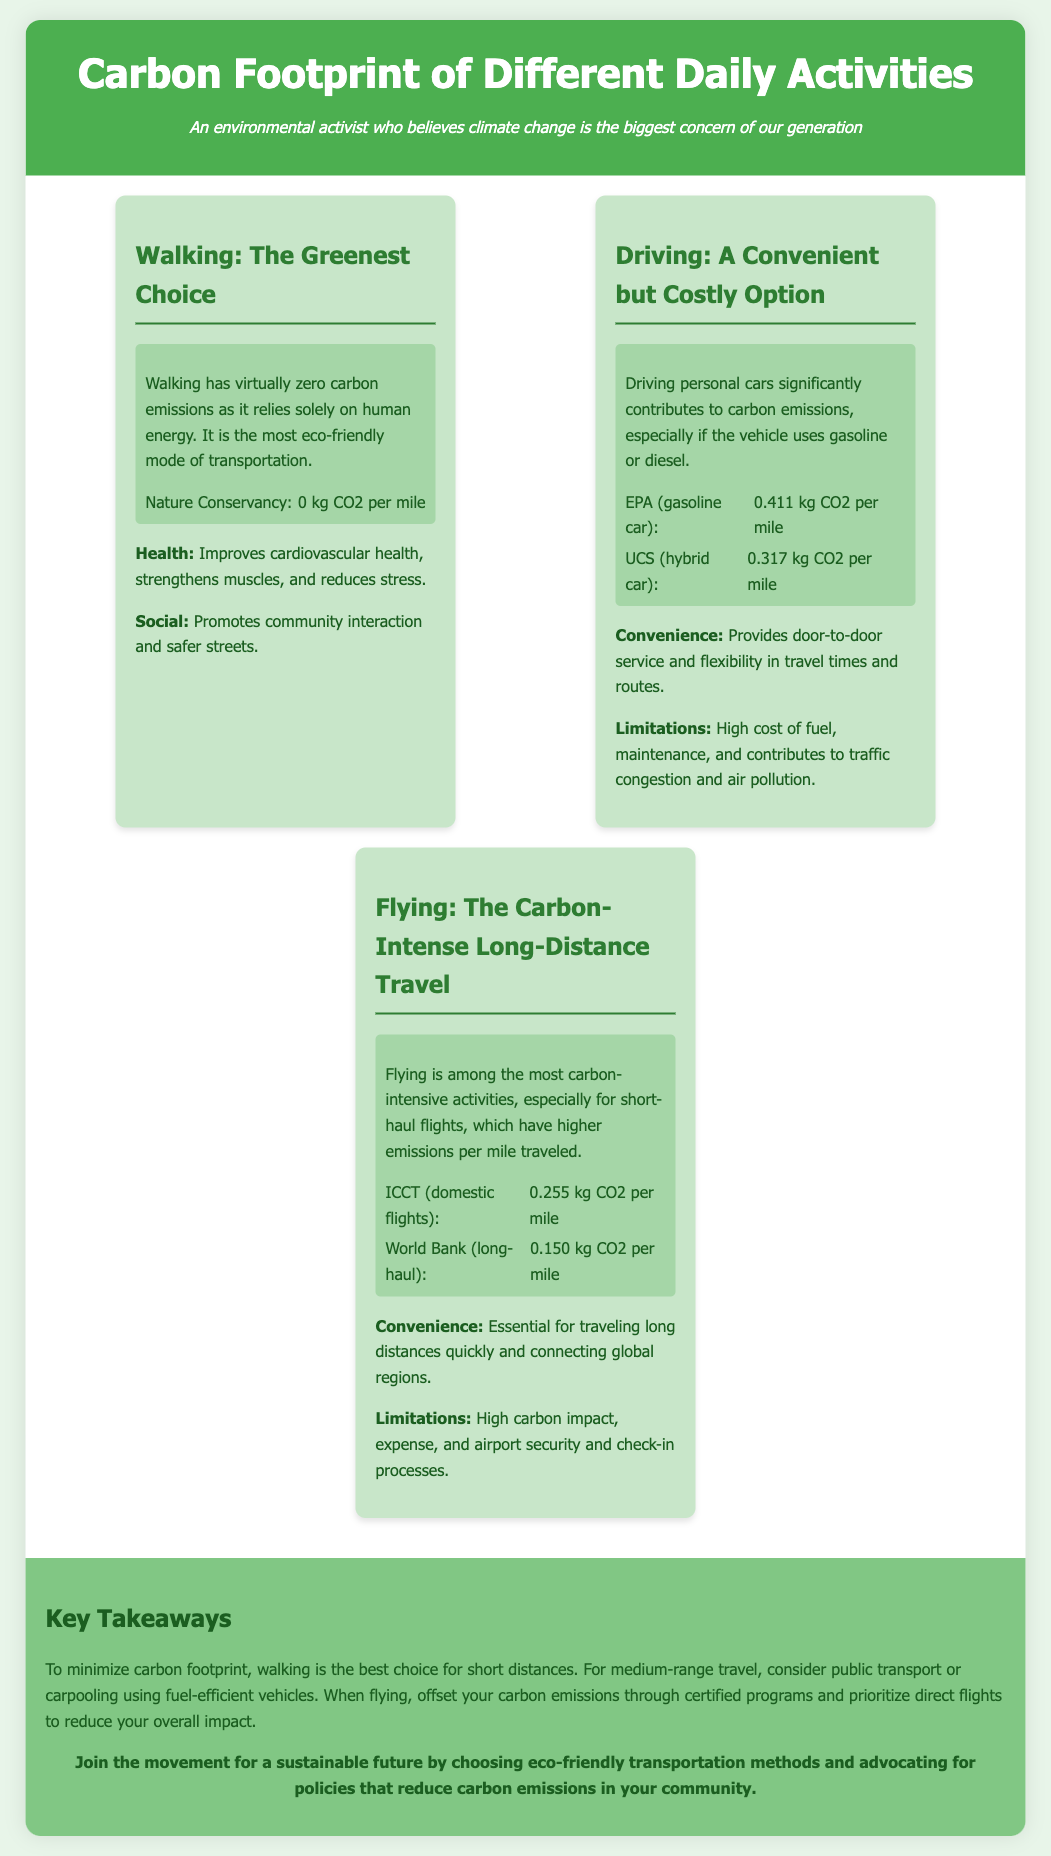What is the carbon footprint of walking? The document states that walking has virtually zero carbon emissions.
Answer: 0 kg CO2 per mile What is the carbon footprint of a gasoline car? The document provides specific figures for carbon emissions from a gasoline car.
Answer: 0.411 kg CO2 per mile How does the carbon footprint of flying compare to driving? The document implies that flying is more carbon-intensive than driving by providing specific CO2 emissions for both activities.
Answer: Higher What are two benefits of walking mentioned in the infographic? The document lists benefits of walking, including improvements in health and social interaction.
Answer: Health and Social What is the carbon footprint of long-haul flights? The document specifies how much carbon emissions come from long-haul flights.
Answer: 0.150 kg CO2 per mile Which activity has the lowest emissions? The infographic compares several activities and identifies the one with the least carbon emissions.
Answer: Walking What does the conclusion suggest for medium-range travel? The document gives advice on making eco-friendly transportation choices for medium-range travel.
Answer: Public transport or carpooling What is one limitation of driving mentioned? The document includes drawbacks related to driving, including maintenance costs and environmental impact.
Answer: High cost of fuel What should individuals do when flying to mitigate their carbon impact? The document offers guidance on reducing carbon emissions while flying.
Answer: Offset carbon emissions through certified programs 